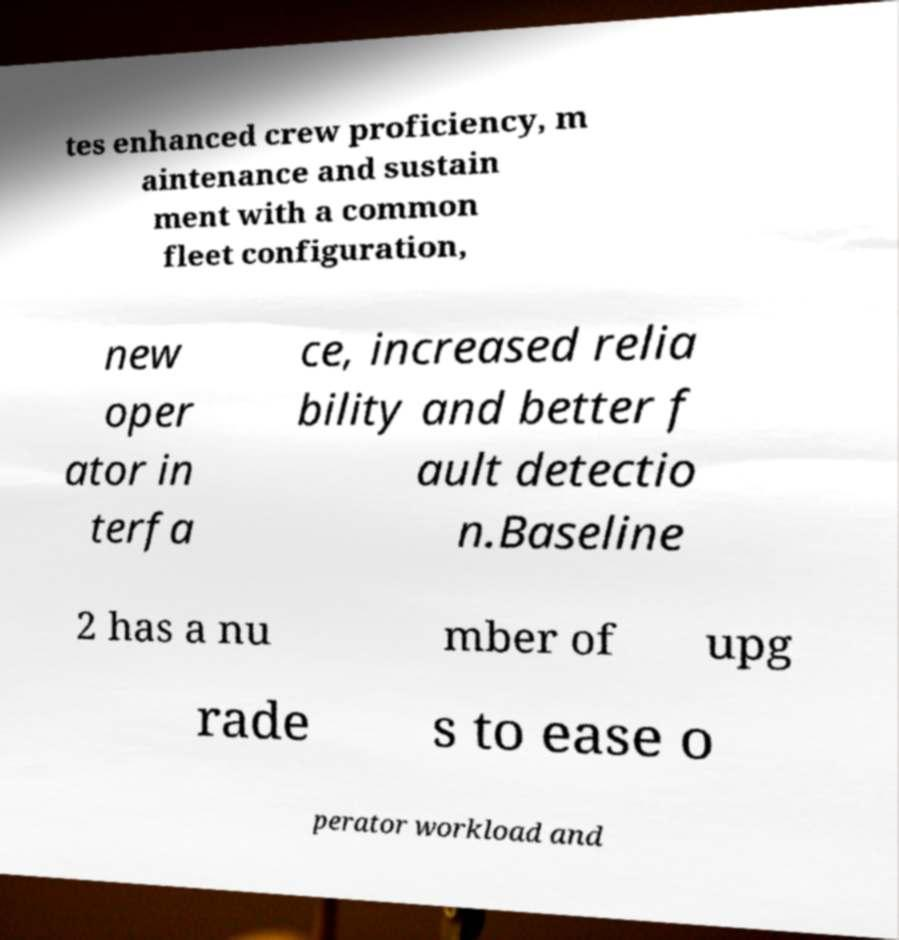What messages or text are displayed in this image? I need them in a readable, typed format. tes enhanced crew proficiency, m aintenance and sustain ment with a common fleet configuration, new oper ator in terfa ce, increased relia bility and better f ault detectio n.Baseline 2 has a nu mber of upg rade s to ease o perator workload and 